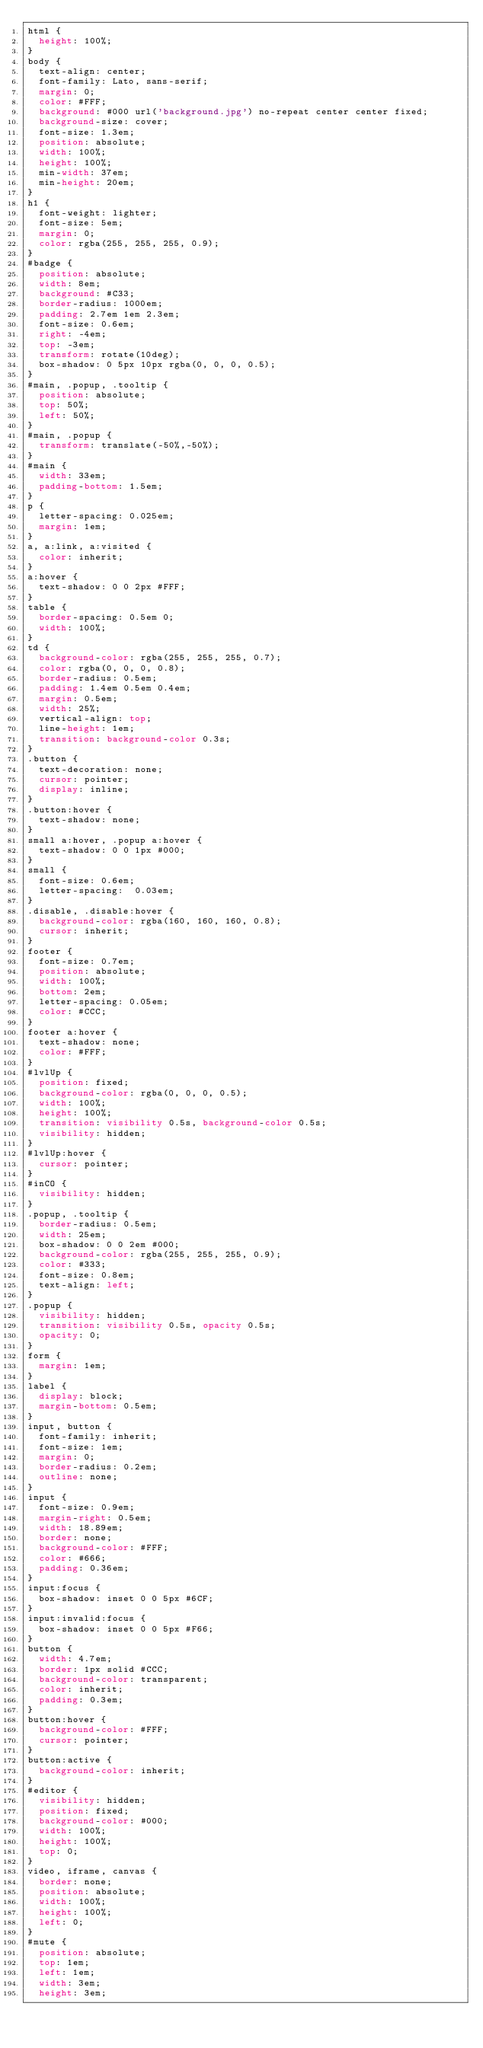<code> <loc_0><loc_0><loc_500><loc_500><_CSS_>html {
  height: 100%;
}
body {
  text-align: center;
  font-family: Lato, sans-serif;
  margin: 0;
  color: #FFF;
  background: #000 url('background.jpg') no-repeat center center fixed;
  background-size: cover;
  font-size: 1.3em;
  position: absolute;
  width: 100%;
  height: 100%;
  min-width: 37em;
  min-height: 20em;
}
h1 {
  font-weight: lighter;
  font-size: 5em;
  margin: 0;
  color: rgba(255, 255, 255, 0.9);
}
#badge {
  position: absolute;
  width: 8em;
  background: #C33;
  border-radius: 1000em;
  padding: 2.7em 1em 2.3em;
  font-size: 0.6em;
  right: -4em;
  top: -3em;
  transform: rotate(10deg);
  box-shadow: 0 5px 10px rgba(0, 0, 0, 0.5);
}
#main, .popup, .tooltip {
  position: absolute;
  top: 50%;
  left: 50%;
}
#main, .popup {
  transform: translate(-50%,-50%);
}
#main {
  width: 33em;
  padding-bottom: 1.5em;
}
p {
  letter-spacing: 0.025em;
  margin: 1em;
}
a, a:link, a:visited {
  color: inherit;
}
a:hover {
  text-shadow: 0 0 2px #FFF;
}
table {
  border-spacing: 0.5em 0;
  width: 100%;
}
td {
  background-color: rgba(255, 255, 255, 0.7);
  color: rgba(0, 0, 0, 0.8);
  border-radius: 0.5em;
  padding: 1.4em 0.5em 0.4em;
  margin: 0.5em;
  width: 25%;
  vertical-align: top;
  line-height: 1em;
  transition: background-color 0.3s;
}
.button {
  text-decoration: none;
  cursor: pointer;
  display: inline;
}
.button:hover {
  text-shadow: none;
}
small a:hover, .popup a:hover {
  text-shadow: 0 0 1px #000;
}
small {
  font-size: 0.6em;
  letter-spacing:  0.03em;
}
.disable, .disable:hover {
  background-color: rgba(160, 160, 160, 0.8);
  cursor: inherit;
}
footer {
  font-size: 0.7em;
  position: absolute;
  width: 100%;
  bottom: 2em;
  letter-spacing: 0.05em;
  color: #CCC;
}
footer a:hover {
  text-shadow: none;
  color: #FFF;
}
#lvlUp {
  position: fixed;
  background-color: rgba(0, 0, 0, 0.5);
  width: 100%;
  height: 100%;
  transition: visibility 0.5s, background-color 0.5s;
  visibility: hidden;
}
#lvlUp:hover {
  cursor: pointer;
}
#inCO {
  visibility: hidden;
}
.popup, .tooltip {
  border-radius: 0.5em;
  width: 25em;
  box-shadow: 0 0 2em #000;
  background-color: rgba(255, 255, 255, 0.9);
  color: #333;
  font-size: 0.8em;
  text-align: left;
}
.popup {
  visibility: hidden;
  transition: visibility 0.5s, opacity 0.5s;
  opacity: 0;
}
form {
  margin: 1em;
}
label {
  display: block;
  margin-bottom: 0.5em;
}
input, button {
  font-family: inherit;
  font-size: 1em;
  margin: 0;
  border-radius: 0.2em;
  outline: none;
}
input {
  font-size: 0.9em;
  margin-right: 0.5em;
  width: 18.89em;
  border: none;
  background-color: #FFF;
  color: #666;
  padding: 0.36em;
}
input:focus {
  box-shadow: inset 0 0 5px #6CF;
}
input:invalid:focus {
  box-shadow: inset 0 0 5px #F66;
}
button {
  width: 4.7em;
  border: 1px solid #CCC;
  background-color: transparent;
  color: inherit;
  padding: 0.3em;
}
button:hover {
  background-color: #FFF;
  cursor: pointer;
}
button:active {
  background-color: inherit;
}
#editor {
  visibility: hidden;
  position: fixed;
  background-color: #000;
  width: 100%;
  height: 100%;
  top: 0;
}
video, iframe, canvas {
  border: none;
  position: absolute;
  width: 100%;
  height: 100%;
  left: 0;
}
#mute {
  position: absolute;
  top: 1em;
  left: 1em;
  width: 3em;
  height: 3em;</code> 